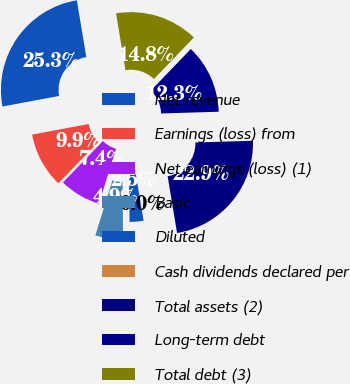<chart> <loc_0><loc_0><loc_500><loc_500><pie_chart><fcel>Net revenue<fcel>Earnings (loss) from<fcel>Net earnings (loss) (1)<fcel>Basic<fcel>Diluted<fcel>Cash dividends declared per<fcel>Total assets (2)<fcel>Long-term debt<fcel>Total debt (3)<nl><fcel>25.32%<fcel>9.87%<fcel>7.4%<fcel>4.94%<fcel>2.47%<fcel>0.0%<fcel>22.85%<fcel>12.34%<fcel>14.81%<nl></chart> 